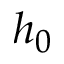Convert formula to latex. <formula><loc_0><loc_0><loc_500><loc_500>h _ { 0 }</formula> 